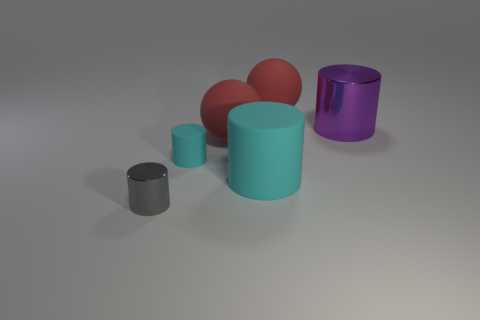How many other things are there of the same color as the big metal cylinder?
Ensure brevity in your answer.  0. There is a purple metal cylinder; is its size the same as the cyan matte object that is in front of the tiny cyan thing?
Your answer should be very brief. Yes. What is the red thing to the left of the sphere behind the large shiny cylinder made of?
Keep it short and to the point. Rubber. Are there an equal number of small gray cylinders that are behind the large purple shiny object and large metallic cylinders?
Your answer should be compact. No. There is a cylinder that is both in front of the tiny cyan rubber thing and behind the gray shiny thing; what size is it?
Make the answer very short. Large. What color is the big object to the left of the rubber object that is in front of the small rubber cylinder?
Ensure brevity in your answer.  Red. What number of cyan objects are tiny matte objects or big matte cylinders?
Provide a succinct answer. 2. What is the color of the big matte object that is both in front of the purple metallic cylinder and behind the big cyan cylinder?
Offer a very short reply. Red. What number of tiny things are shiny cylinders or cylinders?
Give a very brief answer. 2. What size is the gray metallic thing that is the same shape as the large purple object?
Your answer should be compact. Small. 